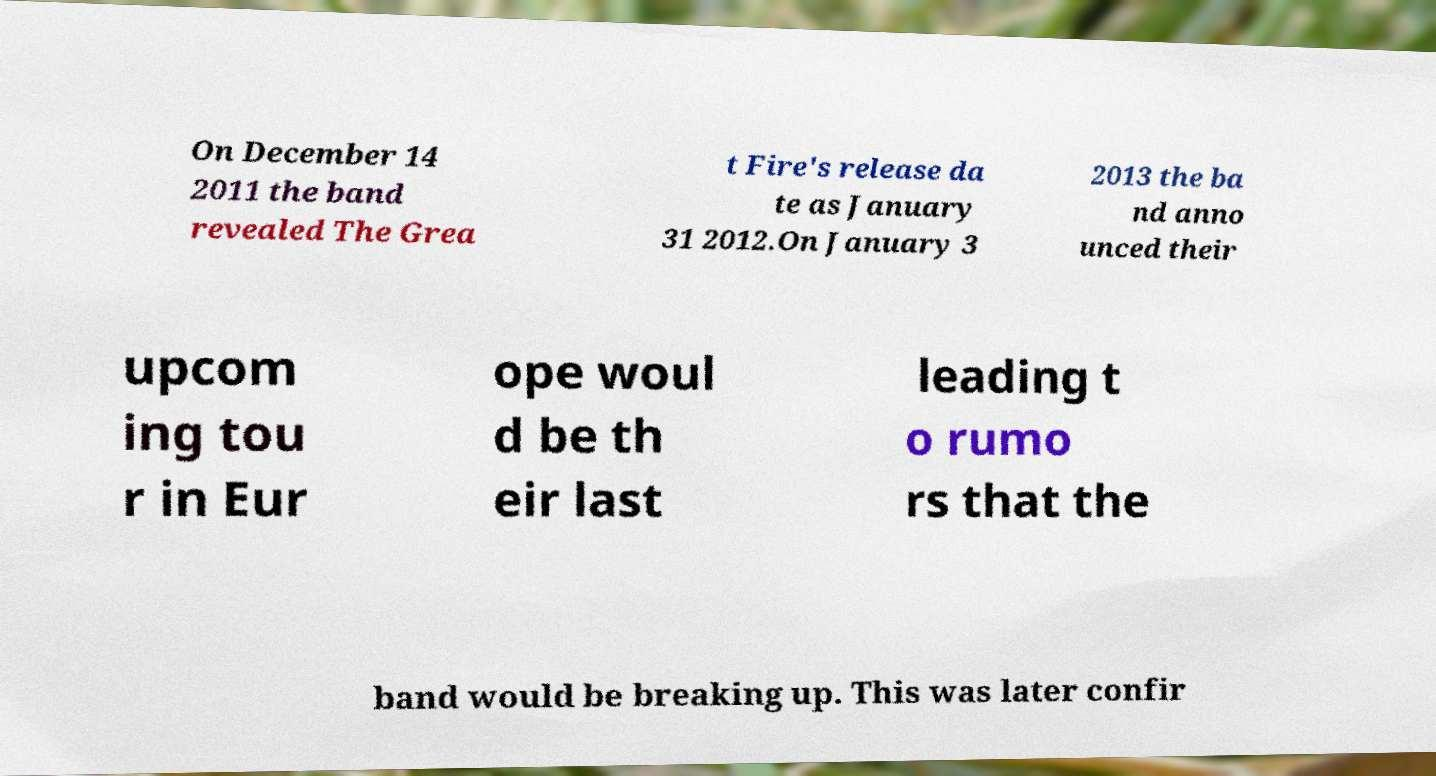Please identify and transcribe the text found in this image. On December 14 2011 the band revealed The Grea t Fire's release da te as January 31 2012.On January 3 2013 the ba nd anno unced their upcom ing tou r in Eur ope woul d be th eir last leading t o rumo rs that the band would be breaking up. This was later confir 